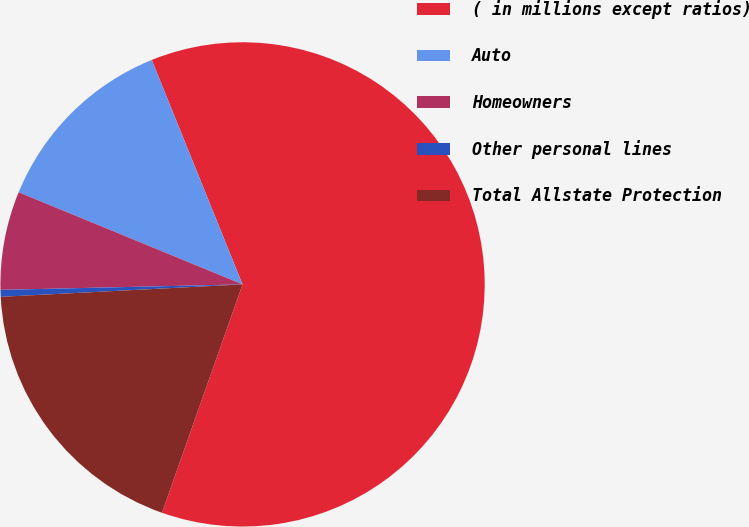Convert chart to OTSL. <chart><loc_0><loc_0><loc_500><loc_500><pie_chart><fcel>( in millions except ratios)<fcel>Auto<fcel>Homeowners<fcel>Other personal lines<fcel>Total Allstate Protection<nl><fcel>61.52%<fcel>12.67%<fcel>6.57%<fcel>0.46%<fcel>18.78%<nl></chart> 